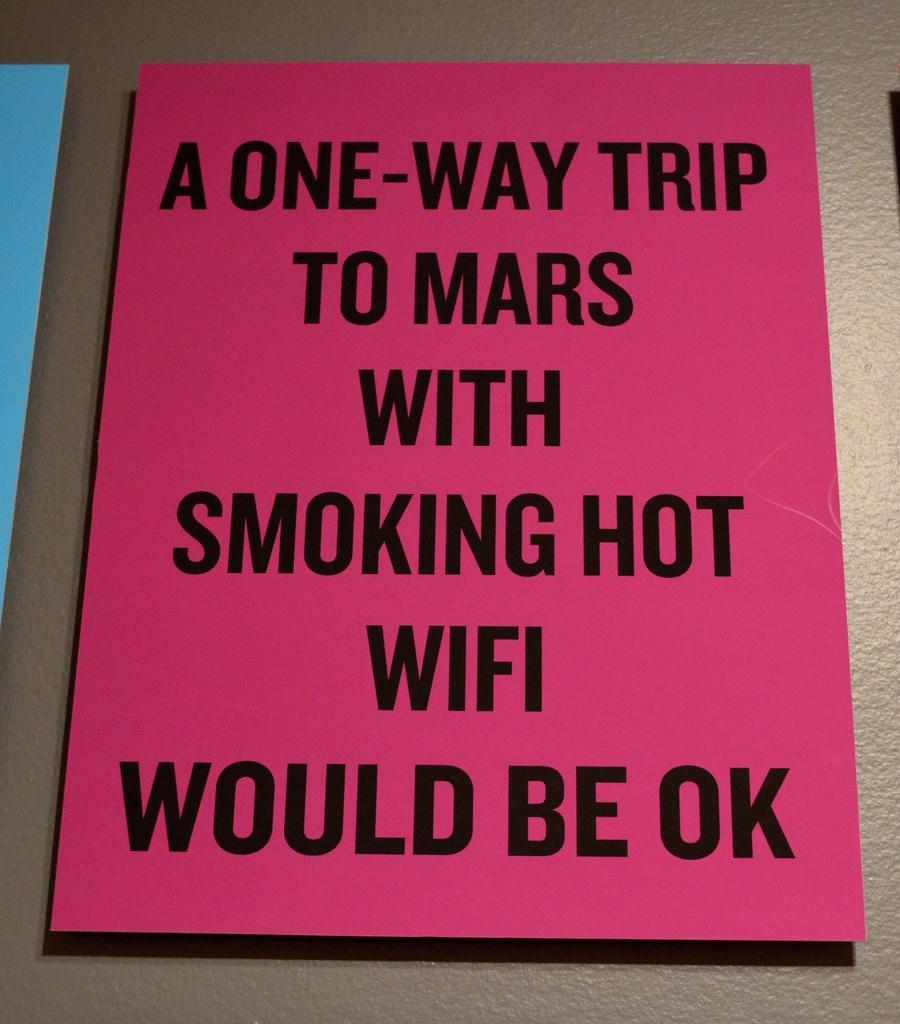Provide a one-sentence caption for the provided image. The sign suggests that a trip to Mars with fast wifi would be okay. 